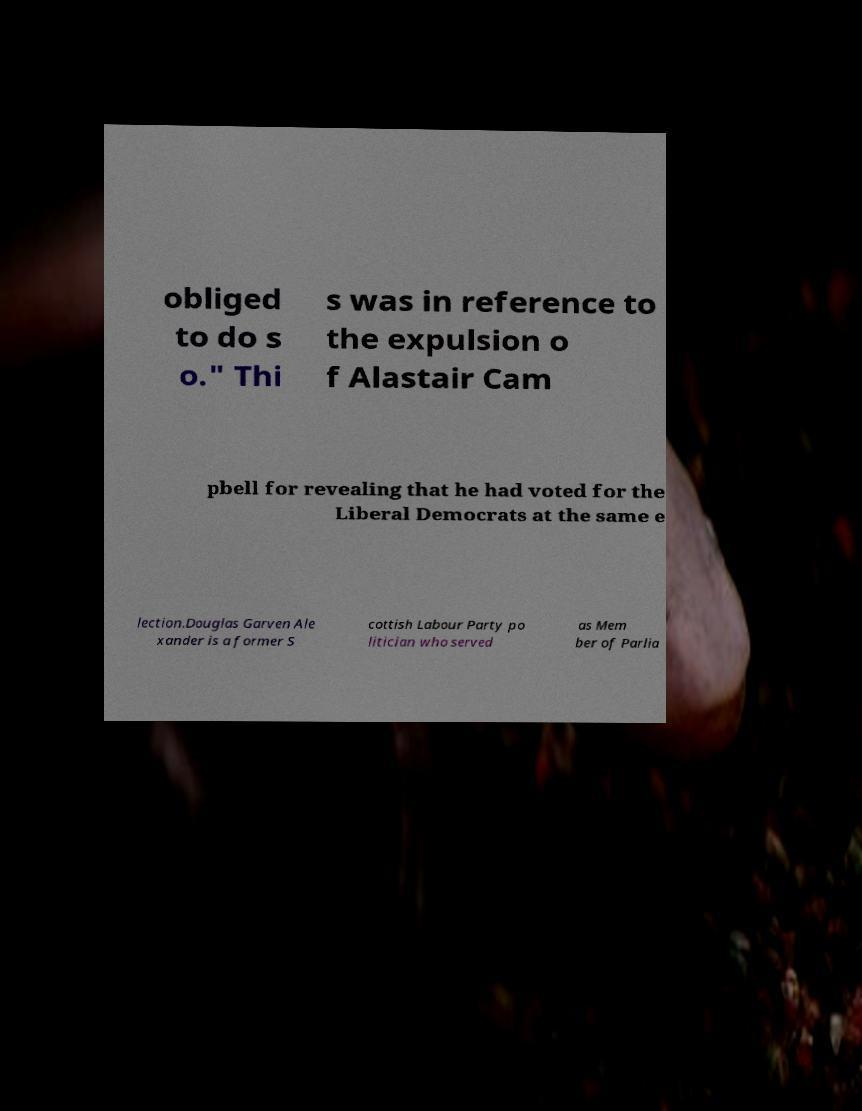What messages or text are displayed in this image? I need them in a readable, typed format. obliged to do s o." Thi s was in reference to the expulsion o f Alastair Cam pbell for revealing that he had voted for the Liberal Democrats at the same e lection.Douglas Garven Ale xander is a former S cottish Labour Party po litician who served as Mem ber of Parlia 